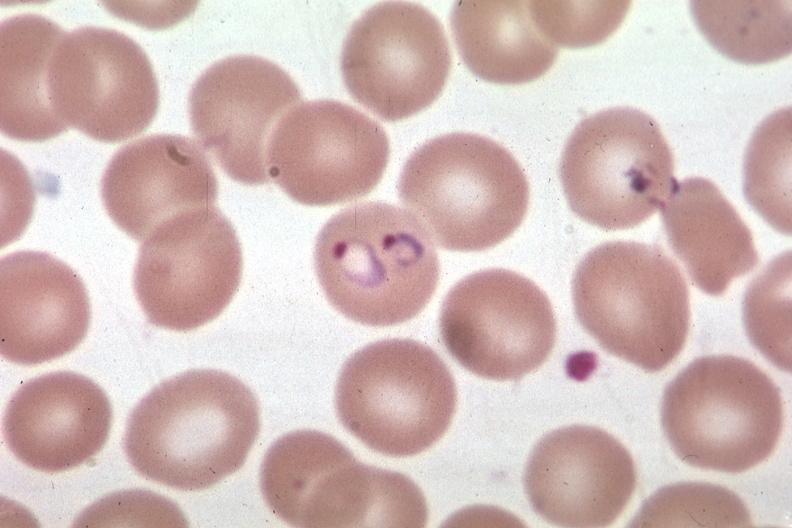what is present?
Answer the question using a single word or phrase. Hematologic 